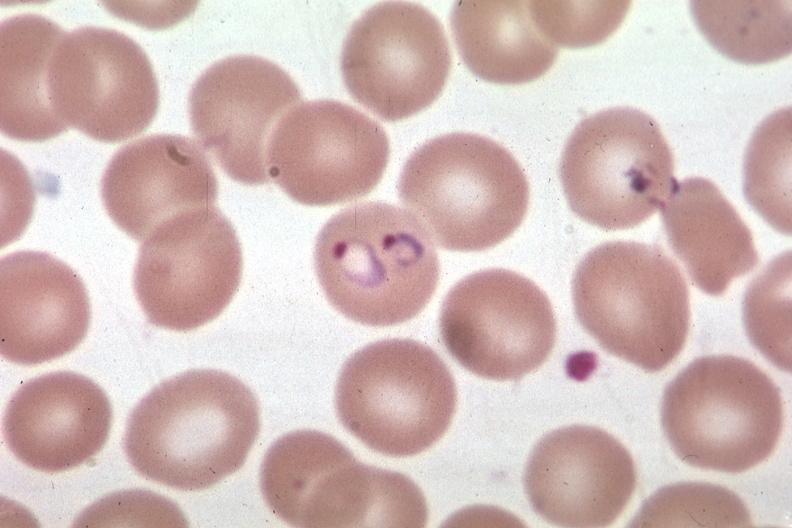what is present?
Answer the question using a single word or phrase. Hematologic 